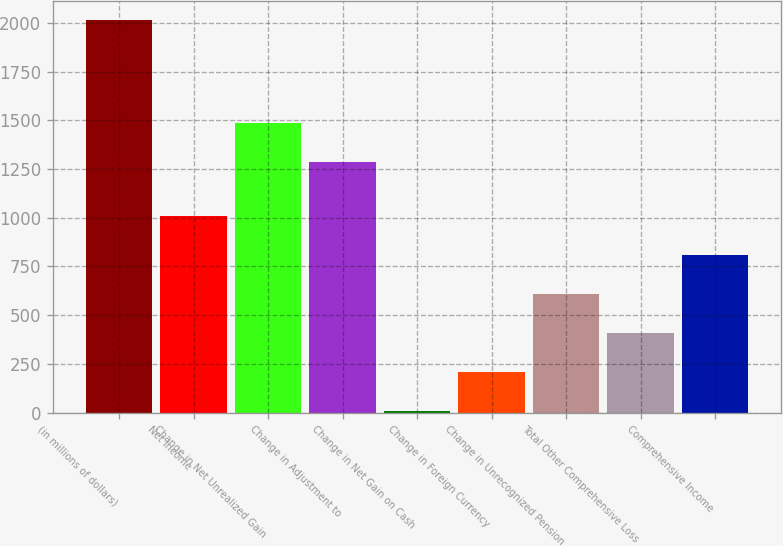Convert chart. <chart><loc_0><loc_0><loc_500><loc_500><bar_chart><fcel>(in millions of dollars)<fcel>Net Income<fcel>Change in Net Unrealized Gain<fcel>Change in Adjustment to<fcel>Change in Net Gain on Cash<fcel>Change in Foreign Currency<fcel>Change in Unrecognized Pension<fcel>Total Other Comprehensive Loss<fcel>Comprehensive Income<nl><fcel>2014<fcel>1009.65<fcel>1485.57<fcel>1284.7<fcel>5.3<fcel>206.17<fcel>607.91<fcel>407.04<fcel>808.78<nl></chart> 